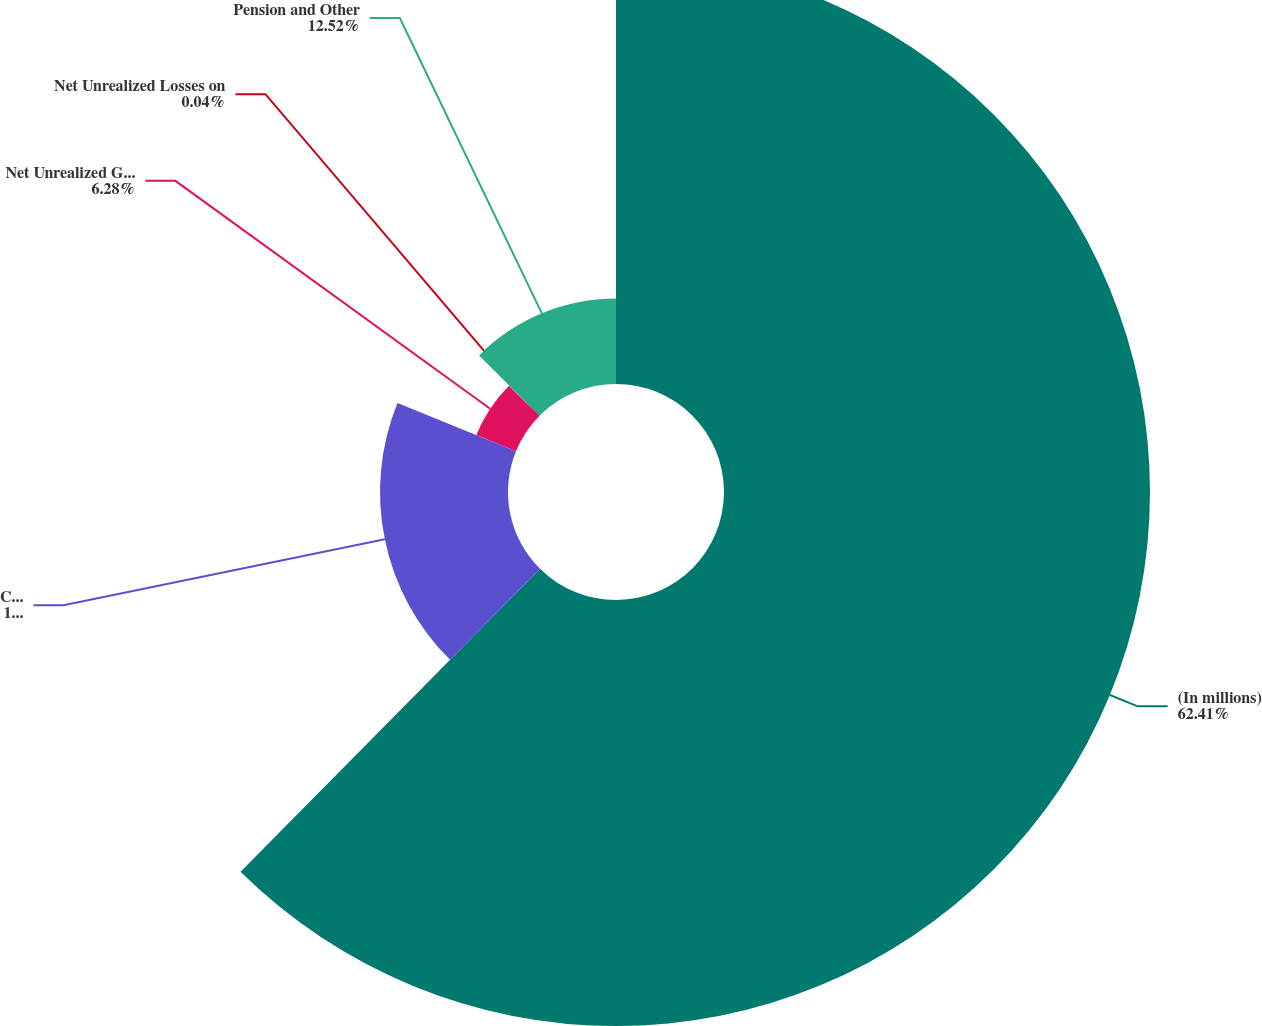Convert chart. <chart><loc_0><loc_0><loc_500><loc_500><pie_chart><fcel>(In millions)<fcel>Cumulative Translation<fcel>Net Unrealized Gain on<fcel>Net Unrealized Losses on<fcel>Pension and Other<nl><fcel>62.41%<fcel>18.75%<fcel>6.28%<fcel>0.04%<fcel>12.52%<nl></chart> 